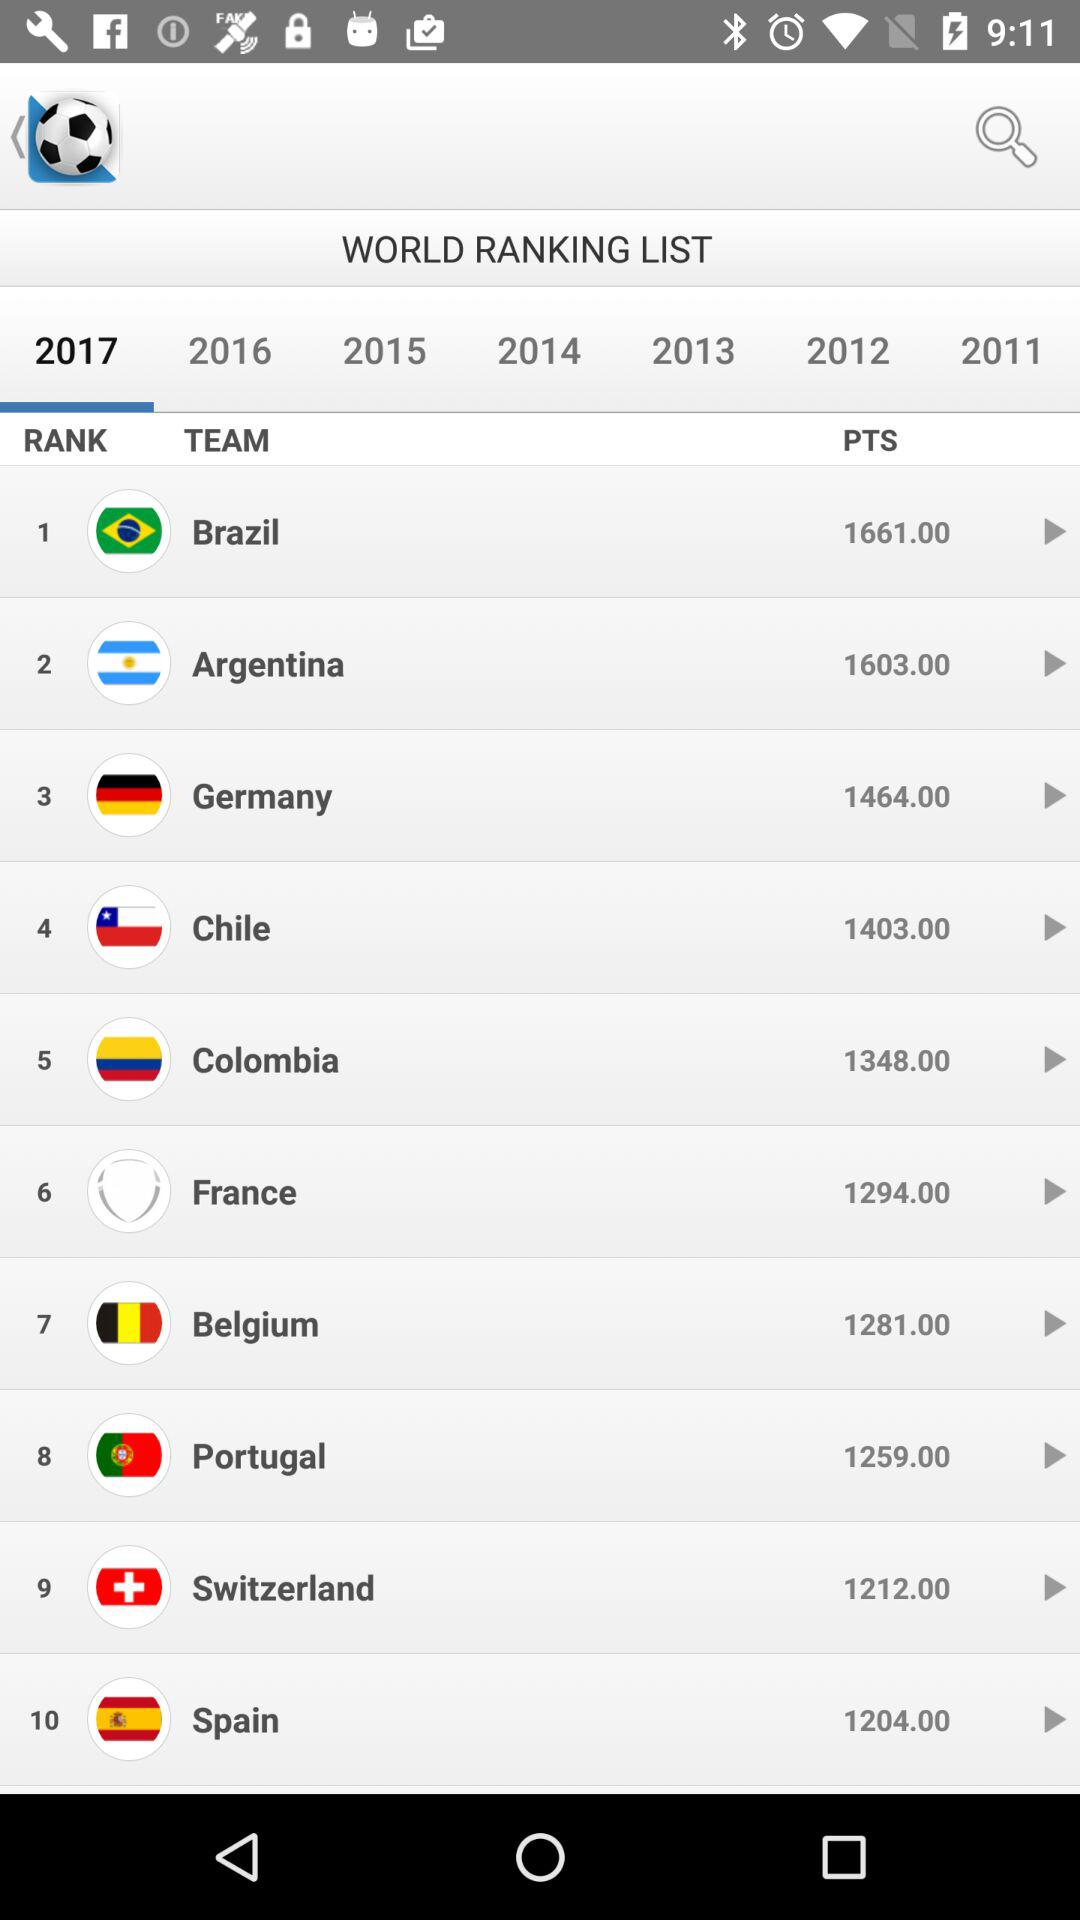How many points does "Brazil" have? "Brazil" has 1661 points. 